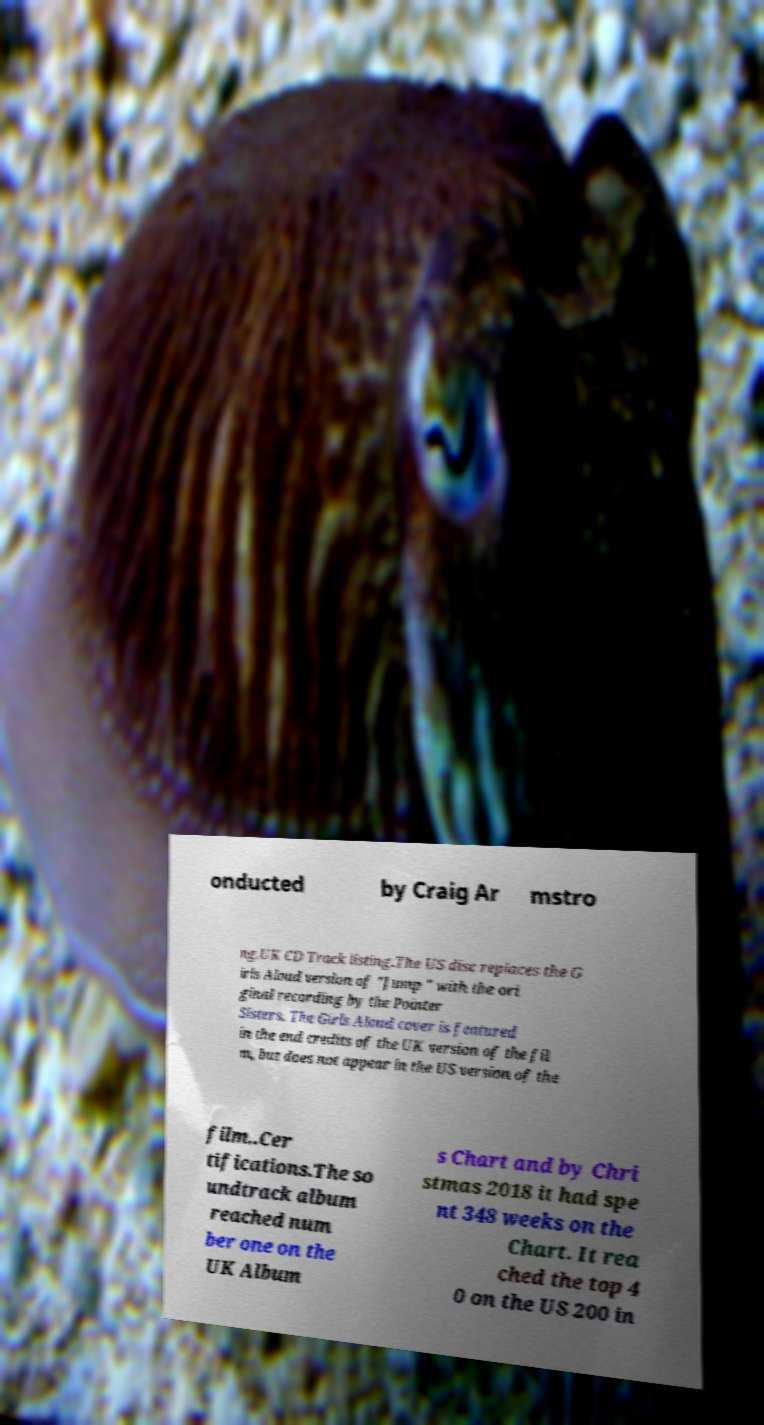Can you accurately transcribe the text from the provided image for me? onducted by Craig Ar mstro ng.UK CD Track listing.The US disc replaces the G irls Aloud version of "Jump " with the ori ginal recording by the Pointer Sisters. The Girls Aloud cover is featured in the end credits of the UK version of the fil m, but does not appear in the US version of the film..Cer tifications.The so undtrack album reached num ber one on the UK Album s Chart and by Chri stmas 2018 it had spe nt 348 weeks on the Chart. It rea ched the top 4 0 on the US 200 in 